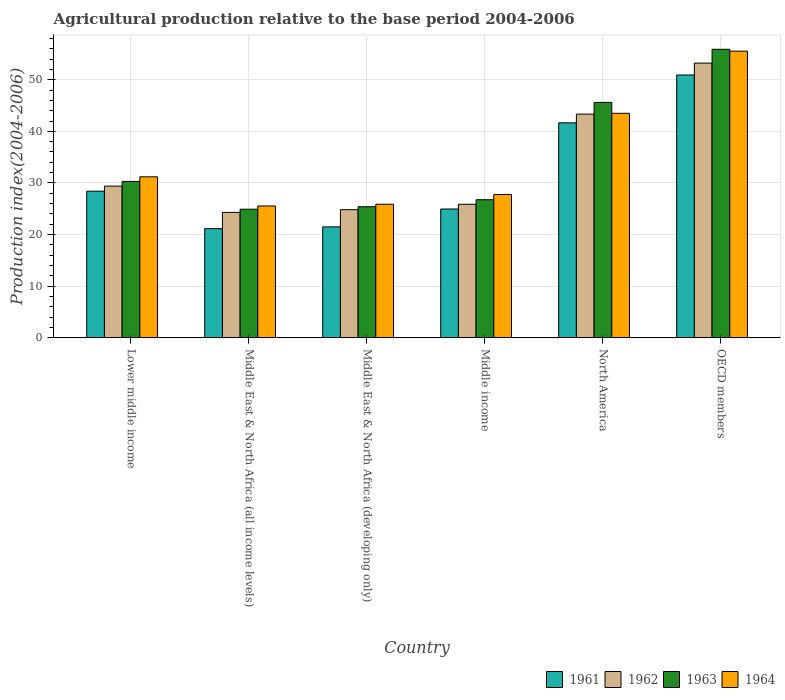How many different coloured bars are there?
Offer a very short reply. 4. How many bars are there on the 6th tick from the right?
Provide a succinct answer. 4. What is the label of the 5th group of bars from the left?
Make the answer very short. North America. In how many cases, is the number of bars for a given country not equal to the number of legend labels?
Provide a short and direct response. 0. What is the agricultural production index in 1961 in Lower middle income?
Make the answer very short. 28.39. Across all countries, what is the maximum agricultural production index in 1964?
Your answer should be compact. 55.54. Across all countries, what is the minimum agricultural production index in 1962?
Offer a terse response. 24.29. In which country was the agricultural production index in 1962 minimum?
Your answer should be compact. Middle East & North Africa (all income levels). What is the total agricultural production index in 1964 in the graph?
Offer a very short reply. 209.37. What is the difference between the agricultural production index in 1962 in Middle East & North Africa (all income levels) and that in Middle income?
Your response must be concise. -1.57. What is the difference between the agricultural production index in 1963 in OECD members and the agricultural production index in 1962 in North America?
Offer a terse response. 12.57. What is the average agricultural production index in 1961 per country?
Offer a very short reply. 31.42. What is the difference between the agricultural production index of/in 1961 and agricultural production index of/in 1963 in Lower middle income?
Provide a succinct answer. -1.9. In how many countries, is the agricultural production index in 1964 greater than 54?
Offer a very short reply. 1. What is the ratio of the agricultural production index in 1962 in Middle East & North Africa (developing only) to that in Middle income?
Provide a short and direct response. 0.96. What is the difference between the highest and the second highest agricultural production index in 1963?
Provide a short and direct response. 15.32. What is the difference between the highest and the lowest agricultural production index in 1963?
Ensure brevity in your answer.  31. Is it the case that in every country, the sum of the agricultural production index in 1962 and agricultural production index in 1964 is greater than the sum of agricultural production index in 1961 and agricultural production index in 1963?
Your answer should be very brief. No. What does the 2nd bar from the right in North America represents?
Give a very brief answer. 1963. How many bars are there?
Keep it short and to the point. 24. Are all the bars in the graph horizontal?
Give a very brief answer. No. How many countries are there in the graph?
Give a very brief answer. 6. What is the difference between two consecutive major ticks on the Y-axis?
Make the answer very short. 10. Are the values on the major ticks of Y-axis written in scientific E-notation?
Your answer should be compact. No. Does the graph contain any zero values?
Your response must be concise. No. How many legend labels are there?
Keep it short and to the point. 4. How are the legend labels stacked?
Offer a terse response. Horizontal. What is the title of the graph?
Your response must be concise. Agricultural production relative to the base period 2004-2006. What is the label or title of the X-axis?
Your answer should be compact. Country. What is the label or title of the Y-axis?
Make the answer very short. Production index(2004-2006). What is the Production index(2004-2006) of 1961 in Lower middle income?
Offer a terse response. 28.39. What is the Production index(2004-2006) in 1962 in Lower middle income?
Your response must be concise. 29.38. What is the Production index(2004-2006) of 1963 in Lower middle income?
Ensure brevity in your answer.  30.29. What is the Production index(2004-2006) of 1964 in Lower middle income?
Give a very brief answer. 31.18. What is the Production index(2004-2006) of 1961 in Middle East & North Africa (all income levels)?
Offer a very short reply. 21.14. What is the Production index(2004-2006) in 1962 in Middle East & North Africa (all income levels)?
Make the answer very short. 24.29. What is the Production index(2004-2006) of 1963 in Middle East & North Africa (all income levels)?
Your response must be concise. 24.9. What is the Production index(2004-2006) in 1964 in Middle East & North Africa (all income levels)?
Give a very brief answer. 25.53. What is the Production index(2004-2006) of 1961 in Middle East & North Africa (developing only)?
Make the answer very short. 21.48. What is the Production index(2004-2006) of 1962 in Middle East & North Africa (developing only)?
Offer a terse response. 24.81. What is the Production index(2004-2006) of 1963 in Middle East & North Africa (developing only)?
Offer a very short reply. 25.39. What is the Production index(2004-2006) of 1964 in Middle East & North Africa (developing only)?
Make the answer very short. 25.86. What is the Production index(2004-2006) of 1961 in Middle income?
Offer a very short reply. 24.94. What is the Production index(2004-2006) in 1962 in Middle income?
Offer a terse response. 25.86. What is the Production index(2004-2006) in 1963 in Middle income?
Keep it short and to the point. 26.74. What is the Production index(2004-2006) in 1964 in Middle income?
Your answer should be very brief. 27.75. What is the Production index(2004-2006) of 1961 in North America?
Your answer should be very brief. 41.65. What is the Production index(2004-2006) in 1962 in North America?
Ensure brevity in your answer.  43.33. What is the Production index(2004-2006) of 1963 in North America?
Make the answer very short. 45.61. What is the Production index(2004-2006) in 1964 in North America?
Give a very brief answer. 43.5. What is the Production index(2004-2006) of 1961 in OECD members?
Keep it short and to the point. 50.92. What is the Production index(2004-2006) in 1962 in OECD members?
Give a very brief answer. 53.23. What is the Production index(2004-2006) of 1963 in OECD members?
Provide a short and direct response. 55.9. What is the Production index(2004-2006) in 1964 in OECD members?
Keep it short and to the point. 55.54. Across all countries, what is the maximum Production index(2004-2006) in 1961?
Your answer should be very brief. 50.92. Across all countries, what is the maximum Production index(2004-2006) of 1962?
Provide a succinct answer. 53.23. Across all countries, what is the maximum Production index(2004-2006) in 1963?
Ensure brevity in your answer.  55.9. Across all countries, what is the maximum Production index(2004-2006) in 1964?
Give a very brief answer. 55.54. Across all countries, what is the minimum Production index(2004-2006) of 1961?
Your response must be concise. 21.14. Across all countries, what is the minimum Production index(2004-2006) of 1962?
Your answer should be compact. 24.29. Across all countries, what is the minimum Production index(2004-2006) in 1963?
Provide a short and direct response. 24.9. Across all countries, what is the minimum Production index(2004-2006) of 1964?
Offer a terse response. 25.53. What is the total Production index(2004-2006) in 1961 in the graph?
Keep it short and to the point. 188.52. What is the total Production index(2004-2006) in 1962 in the graph?
Your answer should be very brief. 200.9. What is the total Production index(2004-2006) in 1963 in the graph?
Your answer should be very brief. 208.83. What is the total Production index(2004-2006) in 1964 in the graph?
Offer a very short reply. 209.37. What is the difference between the Production index(2004-2006) of 1961 in Lower middle income and that in Middle East & North Africa (all income levels)?
Provide a short and direct response. 7.26. What is the difference between the Production index(2004-2006) in 1962 in Lower middle income and that in Middle East & North Africa (all income levels)?
Make the answer very short. 5.09. What is the difference between the Production index(2004-2006) of 1963 in Lower middle income and that in Middle East & North Africa (all income levels)?
Your answer should be very brief. 5.39. What is the difference between the Production index(2004-2006) in 1964 in Lower middle income and that in Middle East & North Africa (all income levels)?
Your response must be concise. 5.66. What is the difference between the Production index(2004-2006) of 1961 in Lower middle income and that in Middle East & North Africa (developing only)?
Make the answer very short. 6.92. What is the difference between the Production index(2004-2006) of 1962 in Lower middle income and that in Middle East & North Africa (developing only)?
Provide a short and direct response. 4.57. What is the difference between the Production index(2004-2006) of 1963 in Lower middle income and that in Middle East & North Africa (developing only)?
Give a very brief answer. 4.9. What is the difference between the Production index(2004-2006) of 1964 in Lower middle income and that in Middle East & North Africa (developing only)?
Ensure brevity in your answer.  5.32. What is the difference between the Production index(2004-2006) of 1961 in Lower middle income and that in Middle income?
Make the answer very short. 3.45. What is the difference between the Production index(2004-2006) of 1962 in Lower middle income and that in Middle income?
Make the answer very short. 3.52. What is the difference between the Production index(2004-2006) in 1963 in Lower middle income and that in Middle income?
Offer a terse response. 3.55. What is the difference between the Production index(2004-2006) in 1964 in Lower middle income and that in Middle income?
Provide a short and direct response. 3.43. What is the difference between the Production index(2004-2006) in 1961 in Lower middle income and that in North America?
Your response must be concise. -13.25. What is the difference between the Production index(2004-2006) in 1962 in Lower middle income and that in North America?
Give a very brief answer. -13.96. What is the difference between the Production index(2004-2006) of 1963 in Lower middle income and that in North America?
Provide a succinct answer. -15.32. What is the difference between the Production index(2004-2006) of 1964 in Lower middle income and that in North America?
Your response must be concise. -12.32. What is the difference between the Production index(2004-2006) in 1961 in Lower middle income and that in OECD members?
Give a very brief answer. -22.53. What is the difference between the Production index(2004-2006) in 1962 in Lower middle income and that in OECD members?
Your answer should be compact. -23.85. What is the difference between the Production index(2004-2006) in 1963 in Lower middle income and that in OECD members?
Provide a succinct answer. -25.61. What is the difference between the Production index(2004-2006) of 1964 in Lower middle income and that in OECD members?
Offer a very short reply. -24.36. What is the difference between the Production index(2004-2006) of 1961 in Middle East & North Africa (all income levels) and that in Middle East & North Africa (developing only)?
Keep it short and to the point. -0.34. What is the difference between the Production index(2004-2006) of 1962 in Middle East & North Africa (all income levels) and that in Middle East & North Africa (developing only)?
Your answer should be very brief. -0.52. What is the difference between the Production index(2004-2006) of 1963 in Middle East & North Africa (all income levels) and that in Middle East & North Africa (developing only)?
Your answer should be very brief. -0.48. What is the difference between the Production index(2004-2006) in 1964 in Middle East & North Africa (all income levels) and that in Middle East & North Africa (developing only)?
Offer a terse response. -0.34. What is the difference between the Production index(2004-2006) in 1961 in Middle East & North Africa (all income levels) and that in Middle income?
Provide a short and direct response. -3.8. What is the difference between the Production index(2004-2006) of 1962 in Middle East & North Africa (all income levels) and that in Middle income?
Keep it short and to the point. -1.57. What is the difference between the Production index(2004-2006) in 1963 in Middle East & North Africa (all income levels) and that in Middle income?
Give a very brief answer. -1.84. What is the difference between the Production index(2004-2006) of 1964 in Middle East & North Africa (all income levels) and that in Middle income?
Give a very brief answer. -2.23. What is the difference between the Production index(2004-2006) of 1961 in Middle East & North Africa (all income levels) and that in North America?
Offer a terse response. -20.51. What is the difference between the Production index(2004-2006) in 1962 in Middle East & North Africa (all income levels) and that in North America?
Offer a very short reply. -19.05. What is the difference between the Production index(2004-2006) of 1963 in Middle East & North Africa (all income levels) and that in North America?
Offer a terse response. -20.71. What is the difference between the Production index(2004-2006) of 1964 in Middle East & North Africa (all income levels) and that in North America?
Offer a terse response. -17.97. What is the difference between the Production index(2004-2006) in 1961 in Middle East & North Africa (all income levels) and that in OECD members?
Your answer should be compact. -29.79. What is the difference between the Production index(2004-2006) in 1962 in Middle East & North Africa (all income levels) and that in OECD members?
Make the answer very short. -28.94. What is the difference between the Production index(2004-2006) in 1963 in Middle East & North Africa (all income levels) and that in OECD members?
Offer a terse response. -31. What is the difference between the Production index(2004-2006) of 1964 in Middle East & North Africa (all income levels) and that in OECD members?
Offer a terse response. -30.02. What is the difference between the Production index(2004-2006) in 1961 in Middle East & North Africa (developing only) and that in Middle income?
Keep it short and to the point. -3.47. What is the difference between the Production index(2004-2006) of 1962 in Middle East & North Africa (developing only) and that in Middle income?
Give a very brief answer. -1.04. What is the difference between the Production index(2004-2006) in 1963 in Middle East & North Africa (developing only) and that in Middle income?
Provide a short and direct response. -1.35. What is the difference between the Production index(2004-2006) of 1964 in Middle East & North Africa (developing only) and that in Middle income?
Your response must be concise. -1.89. What is the difference between the Production index(2004-2006) of 1961 in Middle East & North Africa (developing only) and that in North America?
Provide a succinct answer. -20.17. What is the difference between the Production index(2004-2006) of 1962 in Middle East & North Africa (developing only) and that in North America?
Offer a terse response. -18.52. What is the difference between the Production index(2004-2006) of 1963 in Middle East & North Africa (developing only) and that in North America?
Your answer should be compact. -20.22. What is the difference between the Production index(2004-2006) in 1964 in Middle East & North Africa (developing only) and that in North America?
Offer a very short reply. -17.63. What is the difference between the Production index(2004-2006) of 1961 in Middle East & North Africa (developing only) and that in OECD members?
Make the answer very short. -29.45. What is the difference between the Production index(2004-2006) of 1962 in Middle East & North Africa (developing only) and that in OECD members?
Keep it short and to the point. -28.42. What is the difference between the Production index(2004-2006) of 1963 in Middle East & North Africa (developing only) and that in OECD members?
Keep it short and to the point. -30.52. What is the difference between the Production index(2004-2006) of 1964 in Middle East & North Africa (developing only) and that in OECD members?
Offer a terse response. -29.68. What is the difference between the Production index(2004-2006) in 1961 in Middle income and that in North America?
Offer a terse response. -16.71. What is the difference between the Production index(2004-2006) in 1962 in Middle income and that in North America?
Provide a succinct answer. -17.48. What is the difference between the Production index(2004-2006) of 1963 in Middle income and that in North America?
Give a very brief answer. -18.87. What is the difference between the Production index(2004-2006) of 1964 in Middle income and that in North America?
Your answer should be very brief. -15.75. What is the difference between the Production index(2004-2006) in 1961 in Middle income and that in OECD members?
Offer a very short reply. -25.98. What is the difference between the Production index(2004-2006) in 1962 in Middle income and that in OECD members?
Keep it short and to the point. -27.37. What is the difference between the Production index(2004-2006) of 1963 in Middle income and that in OECD members?
Offer a terse response. -29.16. What is the difference between the Production index(2004-2006) in 1964 in Middle income and that in OECD members?
Your answer should be compact. -27.79. What is the difference between the Production index(2004-2006) in 1961 in North America and that in OECD members?
Make the answer very short. -9.28. What is the difference between the Production index(2004-2006) of 1962 in North America and that in OECD members?
Provide a succinct answer. -9.9. What is the difference between the Production index(2004-2006) of 1963 in North America and that in OECD members?
Your answer should be compact. -10.3. What is the difference between the Production index(2004-2006) in 1964 in North America and that in OECD members?
Offer a very short reply. -12.04. What is the difference between the Production index(2004-2006) in 1961 in Lower middle income and the Production index(2004-2006) in 1962 in Middle East & North Africa (all income levels)?
Offer a terse response. 4.11. What is the difference between the Production index(2004-2006) in 1961 in Lower middle income and the Production index(2004-2006) in 1963 in Middle East & North Africa (all income levels)?
Your answer should be very brief. 3.49. What is the difference between the Production index(2004-2006) of 1961 in Lower middle income and the Production index(2004-2006) of 1964 in Middle East & North Africa (all income levels)?
Provide a short and direct response. 2.87. What is the difference between the Production index(2004-2006) of 1962 in Lower middle income and the Production index(2004-2006) of 1963 in Middle East & North Africa (all income levels)?
Keep it short and to the point. 4.48. What is the difference between the Production index(2004-2006) in 1962 in Lower middle income and the Production index(2004-2006) in 1964 in Middle East & North Africa (all income levels)?
Your answer should be very brief. 3.85. What is the difference between the Production index(2004-2006) of 1963 in Lower middle income and the Production index(2004-2006) of 1964 in Middle East & North Africa (all income levels)?
Make the answer very short. 4.76. What is the difference between the Production index(2004-2006) of 1961 in Lower middle income and the Production index(2004-2006) of 1962 in Middle East & North Africa (developing only)?
Ensure brevity in your answer.  3.58. What is the difference between the Production index(2004-2006) in 1961 in Lower middle income and the Production index(2004-2006) in 1963 in Middle East & North Africa (developing only)?
Offer a terse response. 3.01. What is the difference between the Production index(2004-2006) in 1961 in Lower middle income and the Production index(2004-2006) in 1964 in Middle East & North Africa (developing only)?
Your response must be concise. 2.53. What is the difference between the Production index(2004-2006) in 1962 in Lower middle income and the Production index(2004-2006) in 1963 in Middle East & North Africa (developing only)?
Offer a very short reply. 3.99. What is the difference between the Production index(2004-2006) in 1962 in Lower middle income and the Production index(2004-2006) in 1964 in Middle East & North Africa (developing only)?
Your response must be concise. 3.51. What is the difference between the Production index(2004-2006) in 1963 in Lower middle income and the Production index(2004-2006) in 1964 in Middle East & North Africa (developing only)?
Provide a short and direct response. 4.43. What is the difference between the Production index(2004-2006) of 1961 in Lower middle income and the Production index(2004-2006) of 1962 in Middle income?
Offer a terse response. 2.54. What is the difference between the Production index(2004-2006) in 1961 in Lower middle income and the Production index(2004-2006) in 1963 in Middle income?
Ensure brevity in your answer.  1.65. What is the difference between the Production index(2004-2006) in 1961 in Lower middle income and the Production index(2004-2006) in 1964 in Middle income?
Offer a very short reply. 0.64. What is the difference between the Production index(2004-2006) of 1962 in Lower middle income and the Production index(2004-2006) of 1963 in Middle income?
Keep it short and to the point. 2.64. What is the difference between the Production index(2004-2006) in 1962 in Lower middle income and the Production index(2004-2006) in 1964 in Middle income?
Ensure brevity in your answer.  1.63. What is the difference between the Production index(2004-2006) in 1963 in Lower middle income and the Production index(2004-2006) in 1964 in Middle income?
Offer a terse response. 2.54. What is the difference between the Production index(2004-2006) of 1961 in Lower middle income and the Production index(2004-2006) of 1962 in North America?
Offer a very short reply. -14.94. What is the difference between the Production index(2004-2006) in 1961 in Lower middle income and the Production index(2004-2006) in 1963 in North America?
Your answer should be very brief. -17.21. What is the difference between the Production index(2004-2006) in 1961 in Lower middle income and the Production index(2004-2006) in 1964 in North America?
Ensure brevity in your answer.  -15.1. What is the difference between the Production index(2004-2006) of 1962 in Lower middle income and the Production index(2004-2006) of 1963 in North America?
Keep it short and to the point. -16.23. What is the difference between the Production index(2004-2006) in 1962 in Lower middle income and the Production index(2004-2006) in 1964 in North America?
Provide a short and direct response. -14.12. What is the difference between the Production index(2004-2006) in 1963 in Lower middle income and the Production index(2004-2006) in 1964 in North America?
Ensure brevity in your answer.  -13.21. What is the difference between the Production index(2004-2006) in 1961 in Lower middle income and the Production index(2004-2006) in 1962 in OECD members?
Ensure brevity in your answer.  -24.84. What is the difference between the Production index(2004-2006) of 1961 in Lower middle income and the Production index(2004-2006) of 1963 in OECD members?
Your response must be concise. -27.51. What is the difference between the Production index(2004-2006) in 1961 in Lower middle income and the Production index(2004-2006) in 1964 in OECD members?
Your answer should be compact. -27.15. What is the difference between the Production index(2004-2006) in 1962 in Lower middle income and the Production index(2004-2006) in 1963 in OECD members?
Ensure brevity in your answer.  -26.52. What is the difference between the Production index(2004-2006) in 1962 in Lower middle income and the Production index(2004-2006) in 1964 in OECD members?
Ensure brevity in your answer.  -26.16. What is the difference between the Production index(2004-2006) of 1963 in Lower middle income and the Production index(2004-2006) of 1964 in OECD members?
Your answer should be very brief. -25.25. What is the difference between the Production index(2004-2006) of 1961 in Middle East & North Africa (all income levels) and the Production index(2004-2006) of 1962 in Middle East & North Africa (developing only)?
Your answer should be compact. -3.68. What is the difference between the Production index(2004-2006) in 1961 in Middle East & North Africa (all income levels) and the Production index(2004-2006) in 1963 in Middle East & North Africa (developing only)?
Offer a terse response. -4.25. What is the difference between the Production index(2004-2006) of 1961 in Middle East & North Africa (all income levels) and the Production index(2004-2006) of 1964 in Middle East & North Africa (developing only)?
Keep it short and to the point. -4.73. What is the difference between the Production index(2004-2006) of 1962 in Middle East & North Africa (all income levels) and the Production index(2004-2006) of 1963 in Middle East & North Africa (developing only)?
Give a very brief answer. -1.1. What is the difference between the Production index(2004-2006) of 1962 in Middle East & North Africa (all income levels) and the Production index(2004-2006) of 1964 in Middle East & North Africa (developing only)?
Keep it short and to the point. -1.58. What is the difference between the Production index(2004-2006) of 1963 in Middle East & North Africa (all income levels) and the Production index(2004-2006) of 1964 in Middle East & North Africa (developing only)?
Your answer should be very brief. -0.96. What is the difference between the Production index(2004-2006) in 1961 in Middle East & North Africa (all income levels) and the Production index(2004-2006) in 1962 in Middle income?
Offer a very short reply. -4.72. What is the difference between the Production index(2004-2006) of 1961 in Middle East & North Africa (all income levels) and the Production index(2004-2006) of 1963 in Middle income?
Provide a short and direct response. -5.6. What is the difference between the Production index(2004-2006) of 1961 in Middle East & North Africa (all income levels) and the Production index(2004-2006) of 1964 in Middle income?
Keep it short and to the point. -6.61. What is the difference between the Production index(2004-2006) in 1962 in Middle East & North Africa (all income levels) and the Production index(2004-2006) in 1963 in Middle income?
Offer a very short reply. -2.45. What is the difference between the Production index(2004-2006) in 1962 in Middle East & North Africa (all income levels) and the Production index(2004-2006) in 1964 in Middle income?
Provide a short and direct response. -3.46. What is the difference between the Production index(2004-2006) of 1963 in Middle East & North Africa (all income levels) and the Production index(2004-2006) of 1964 in Middle income?
Your answer should be compact. -2.85. What is the difference between the Production index(2004-2006) of 1961 in Middle East & North Africa (all income levels) and the Production index(2004-2006) of 1962 in North America?
Offer a very short reply. -22.2. What is the difference between the Production index(2004-2006) in 1961 in Middle East & North Africa (all income levels) and the Production index(2004-2006) in 1963 in North America?
Offer a very short reply. -24.47. What is the difference between the Production index(2004-2006) of 1961 in Middle East & North Africa (all income levels) and the Production index(2004-2006) of 1964 in North America?
Offer a terse response. -22.36. What is the difference between the Production index(2004-2006) of 1962 in Middle East & North Africa (all income levels) and the Production index(2004-2006) of 1963 in North America?
Your answer should be very brief. -21.32. What is the difference between the Production index(2004-2006) of 1962 in Middle East & North Africa (all income levels) and the Production index(2004-2006) of 1964 in North America?
Make the answer very short. -19.21. What is the difference between the Production index(2004-2006) of 1963 in Middle East & North Africa (all income levels) and the Production index(2004-2006) of 1964 in North America?
Your answer should be compact. -18.6. What is the difference between the Production index(2004-2006) in 1961 in Middle East & North Africa (all income levels) and the Production index(2004-2006) in 1962 in OECD members?
Offer a terse response. -32.09. What is the difference between the Production index(2004-2006) of 1961 in Middle East & North Africa (all income levels) and the Production index(2004-2006) of 1963 in OECD members?
Your answer should be compact. -34.77. What is the difference between the Production index(2004-2006) in 1961 in Middle East & North Africa (all income levels) and the Production index(2004-2006) in 1964 in OECD members?
Offer a very short reply. -34.4. What is the difference between the Production index(2004-2006) of 1962 in Middle East & North Africa (all income levels) and the Production index(2004-2006) of 1963 in OECD members?
Keep it short and to the point. -31.62. What is the difference between the Production index(2004-2006) of 1962 in Middle East & North Africa (all income levels) and the Production index(2004-2006) of 1964 in OECD members?
Provide a short and direct response. -31.25. What is the difference between the Production index(2004-2006) of 1963 in Middle East & North Africa (all income levels) and the Production index(2004-2006) of 1964 in OECD members?
Offer a terse response. -30.64. What is the difference between the Production index(2004-2006) of 1961 in Middle East & North Africa (developing only) and the Production index(2004-2006) of 1962 in Middle income?
Ensure brevity in your answer.  -4.38. What is the difference between the Production index(2004-2006) in 1961 in Middle East & North Africa (developing only) and the Production index(2004-2006) in 1963 in Middle income?
Keep it short and to the point. -5.26. What is the difference between the Production index(2004-2006) in 1961 in Middle East & North Africa (developing only) and the Production index(2004-2006) in 1964 in Middle income?
Give a very brief answer. -6.28. What is the difference between the Production index(2004-2006) in 1962 in Middle East & North Africa (developing only) and the Production index(2004-2006) in 1963 in Middle income?
Keep it short and to the point. -1.93. What is the difference between the Production index(2004-2006) in 1962 in Middle East & North Africa (developing only) and the Production index(2004-2006) in 1964 in Middle income?
Your response must be concise. -2.94. What is the difference between the Production index(2004-2006) of 1963 in Middle East & North Africa (developing only) and the Production index(2004-2006) of 1964 in Middle income?
Ensure brevity in your answer.  -2.37. What is the difference between the Production index(2004-2006) of 1961 in Middle East & North Africa (developing only) and the Production index(2004-2006) of 1962 in North America?
Your response must be concise. -21.86. What is the difference between the Production index(2004-2006) of 1961 in Middle East & North Africa (developing only) and the Production index(2004-2006) of 1963 in North America?
Ensure brevity in your answer.  -24.13. What is the difference between the Production index(2004-2006) of 1961 in Middle East & North Africa (developing only) and the Production index(2004-2006) of 1964 in North America?
Ensure brevity in your answer.  -22.02. What is the difference between the Production index(2004-2006) in 1962 in Middle East & North Africa (developing only) and the Production index(2004-2006) in 1963 in North America?
Keep it short and to the point. -20.79. What is the difference between the Production index(2004-2006) of 1962 in Middle East & North Africa (developing only) and the Production index(2004-2006) of 1964 in North America?
Your response must be concise. -18.69. What is the difference between the Production index(2004-2006) in 1963 in Middle East & North Africa (developing only) and the Production index(2004-2006) in 1964 in North America?
Keep it short and to the point. -18.11. What is the difference between the Production index(2004-2006) of 1961 in Middle East & North Africa (developing only) and the Production index(2004-2006) of 1962 in OECD members?
Your answer should be compact. -31.76. What is the difference between the Production index(2004-2006) in 1961 in Middle East & North Africa (developing only) and the Production index(2004-2006) in 1963 in OECD members?
Provide a short and direct response. -34.43. What is the difference between the Production index(2004-2006) in 1961 in Middle East & North Africa (developing only) and the Production index(2004-2006) in 1964 in OECD members?
Your response must be concise. -34.07. What is the difference between the Production index(2004-2006) in 1962 in Middle East & North Africa (developing only) and the Production index(2004-2006) in 1963 in OECD members?
Ensure brevity in your answer.  -31.09. What is the difference between the Production index(2004-2006) in 1962 in Middle East & North Africa (developing only) and the Production index(2004-2006) in 1964 in OECD members?
Keep it short and to the point. -30.73. What is the difference between the Production index(2004-2006) of 1963 in Middle East & North Africa (developing only) and the Production index(2004-2006) of 1964 in OECD members?
Your answer should be compact. -30.16. What is the difference between the Production index(2004-2006) in 1961 in Middle income and the Production index(2004-2006) in 1962 in North America?
Your response must be concise. -18.39. What is the difference between the Production index(2004-2006) of 1961 in Middle income and the Production index(2004-2006) of 1963 in North America?
Offer a terse response. -20.67. What is the difference between the Production index(2004-2006) in 1961 in Middle income and the Production index(2004-2006) in 1964 in North America?
Offer a very short reply. -18.56. What is the difference between the Production index(2004-2006) in 1962 in Middle income and the Production index(2004-2006) in 1963 in North America?
Keep it short and to the point. -19.75. What is the difference between the Production index(2004-2006) in 1962 in Middle income and the Production index(2004-2006) in 1964 in North America?
Give a very brief answer. -17.64. What is the difference between the Production index(2004-2006) of 1963 in Middle income and the Production index(2004-2006) of 1964 in North America?
Ensure brevity in your answer.  -16.76. What is the difference between the Production index(2004-2006) of 1961 in Middle income and the Production index(2004-2006) of 1962 in OECD members?
Provide a succinct answer. -28.29. What is the difference between the Production index(2004-2006) of 1961 in Middle income and the Production index(2004-2006) of 1963 in OECD members?
Offer a very short reply. -30.96. What is the difference between the Production index(2004-2006) in 1961 in Middle income and the Production index(2004-2006) in 1964 in OECD members?
Offer a terse response. -30.6. What is the difference between the Production index(2004-2006) of 1962 in Middle income and the Production index(2004-2006) of 1963 in OECD members?
Offer a terse response. -30.05. What is the difference between the Production index(2004-2006) of 1962 in Middle income and the Production index(2004-2006) of 1964 in OECD members?
Offer a terse response. -29.68. What is the difference between the Production index(2004-2006) of 1963 in Middle income and the Production index(2004-2006) of 1964 in OECD members?
Offer a terse response. -28.8. What is the difference between the Production index(2004-2006) of 1961 in North America and the Production index(2004-2006) of 1962 in OECD members?
Offer a terse response. -11.58. What is the difference between the Production index(2004-2006) in 1961 in North America and the Production index(2004-2006) in 1963 in OECD members?
Your response must be concise. -14.26. What is the difference between the Production index(2004-2006) of 1961 in North America and the Production index(2004-2006) of 1964 in OECD members?
Make the answer very short. -13.9. What is the difference between the Production index(2004-2006) in 1962 in North America and the Production index(2004-2006) in 1963 in OECD members?
Your answer should be very brief. -12.57. What is the difference between the Production index(2004-2006) of 1962 in North America and the Production index(2004-2006) of 1964 in OECD members?
Give a very brief answer. -12.21. What is the difference between the Production index(2004-2006) in 1963 in North America and the Production index(2004-2006) in 1964 in OECD members?
Provide a short and direct response. -9.93. What is the average Production index(2004-2006) of 1961 per country?
Provide a succinct answer. 31.42. What is the average Production index(2004-2006) in 1962 per country?
Give a very brief answer. 33.48. What is the average Production index(2004-2006) in 1963 per country?
Provide a succinct answer. 34.8. What is the average Production index(2004-2006) in 1964 per country?
Your answer should be very brief. 34.89. What is the difference between the Production index(2004-2006) of 1961 and Production index(2004-2006) of 1962 in Lower middle income?
Ensure brevity in your answer.  -0.99. What is the difference between the Production index(2004-2006) of 1961 and Production index(2004-2006) of 1963 in Lower middle income?
Your answer should be very brief. -1.9. What is the difference between the Production index(2004-2006) in 1961 and Production index(2004-2006) in 1964 in Lower middle income?
Ensure brevity in your answer.  -2.79. What is the difference between the Production index(2004-2006) in 1962 and Production index(2004-2006) in 1963 in Lower middle income?
Give a very brief answer. -0.91. What is the difference between the Production index(2004-2006) of 1962 and Production index(2004-2006) of 1964 in Lower middle income?
Offer a terse response. -1.8. What is the difference between the Production index(2004-2006) in 1963 and Production index(2004-2006) in 1964 in Lower middle income?
Give a very brief answer. -0.89. What is the difference between the Production index(2004-2006) in 1961 and Production index(2004-2006) in 1962 in Middle East & North Africa (all income levels)?
Ensure brevity in your answer.  -3.15. What is the difference between the Production index(2004-2006) in 1961 and Production index(2004-2006) in 1963 in Middle East & North Africa (all income levels)?
Your answer should be very brief. -3.76. What is the difference between the Production index(2004-2006) of 1961 and Production index(2004-2006) of 1964 in Middle East & North Africa (all income levels)?
Give a very brief answer. -4.39. What is the difference between the Production index(2004-2006) in 1962 and Production index(2004-2006) in 1963 in Middle East & North Africa (all income levels)?
Offer a very short reply. -0.61. What is the difference between the Production index(2004-2006) of 1962 and Production index(2004-2006) of 1964 in Middle East & North Africa (all income levels)?
Your answer should be very brief. -1.24. What is the difference between the Production index(2004-2006) of 1963 and Production index(2004-2006) of 1964 in Middle East & North Africa (all income levels)?
Provide a short and direct response. -0.62. What is the difference between the Production index(2004-2006) of 1961 and Production index(2004-2006) of 1962 in Middle East & North Africa (developing only)?
Offer a terse response. -3.34. What is the difference between the Production index(2004-2006) in 1961 and Production index(2004-2006) in 1963 in Middle East & North Africa (developing only)?
Ensure brevity in your answer.  -3.91. What is the difference between the Production index(2004-2006) of 1961 and Production index(2004-2006) of 1964 in Middle East & North Africa (developing only)?
Offer a terse response. -4.39. What is the difference between the Production index(2004-2006) of 1962 and Production index(2004-2006) of 1963 in Middle East & North Africa (developing only)?
Your answer should be very brief. -0.57. What is the difference between the Production index(2004-2006) of 1962 and Production index(2004-2006) of 1964 in Middle East & North Africa (developing only)?
Keep it short and to the point. -1.05. What is the difference between the Production index(2004-2006) of 1963 and Production index(2004-2006) of 1964 in Middle East & North Africa (developing only)?
Give a very brief answer. -0.48. What is the difference between the Production index(2004-2006) of 1961 and Production index(2004-2006) of 1962 in Middle income?
Your answer should be very brief. -0.92. What is the difference between the Production index(2004-2006) of 1961 and Production index(2004-2006) of 1963 in Middle income?
Offer a terse response. -1.8. What is the difference between the Production index(2004-2006) in 1961 and Production index(2004-2006) in 1964 in Middle income?
Offer a very short reply. -2.81. What is the difference between the Production index(2004-2006) of 1962 and Production index(2004-2006) of 1963 in Middle income?
Your answer should be very brief. -0.88. What is the difference between the Production index(2004-2006) of 1962 and Production index(2004-2006) of 1964 in Middle income?
Ensure brevity in your answer.  -1.89. What is the difference between the Production index(2004-2006) of 1963 and Production index(2004-2006) of 1964 in Middle income?
Your answer should be very brief. -1.01. What is the difference between the Production index(2004-2006) of 1961 and Production index(2004-2006) of 1962 in North America?
Ensure brevity in your answer.  -1.69. What is the difference between the Production index(2004-2006) of 1961 and Production index(2004-2006) of 1963 in North America?
Offer a terse response. -3.96. What is the difference between the Production index(2004-2006) of 1961 and Production index(2004-2006) of 1964 in North America?
Provide a succinct answer. -1.85. What is the difference between the Production index(2004-2006) of 1962 and Production index(2004-2006) of 1963 in North America?
Make the answer very short. -2.27. What is the difference between the Production index(2004-2006) of 1962 and Production index(2004-2006) of 1964 in North America?
Ensure brevity in your answer.  -0.16. What is the difference between the Production index(2004-2006) of 1963 and Production index(2004-2006) of 1964 in North America?
Provide a short and direct response. 2.11. What is the difference between the Production index(2004-2006) in 1961 and Production index(2004-2006) in 1962 in OECD members?
Provide a short and direct response. -2.31. What is the difference between the Production index(2004-2006) in 1961 and Production index(2004-2006) in 1963 in OECD members?
Give a very brief answer. -4.98. What is the difference between the Production index(2004-2006) in 1961 and Production index(2004-2006) in 1964 in OECD members?
Give a very brief answer. -4.62. What is the difference between the Production index(2004-2006) of 1962 and Production index(2004-2006) of 1963 in OECD members?
Your response must be concise. -2.67. What is the difference between the Production index(2004-2006) of 1962 and Production index(2004-2006) of 1964 in OECD members?
Ensure brevity in your answer.  -2.31. What is the difference between the Production index(2004-2006) of 1963 and Production index(2004-2006) of 1964 in OECD members?
Make the answer very short. 0.36. What is the ratio of the Production index(2004-2006) of 1961 in Lower middle income to that in Middle East & North Africa (all income levels)?
Your response must be concise. 1.34. What is the ratio of the Production index(2004-2006) in 1962 in Lower middle income to that in Middle East & North Africa (all income levels)?
Provide a succinct answer. 1.21. What is the ratio of the Production index(2004-2006) in 1963 in Lower middle income to that in Middle East & North Africa (all income levels)?
Offer a very short reply. 1.22. What is the ratio of the Production index(2004-2006) in 1964 in Lower middle income to that in Middle East & North Africa (all income levels)?
Your answer should be very brief. 1.22. What is the ratio of the Production index(2004-2006) in 1961 in Lower middle income to that in Middle East & North Africa (developing only)?
Provide a succinct answer. 1.32. What is the ratio of the Production index(2004-2006) in 1962 in Lower middle income to that in Middle East & North Africa (developing only)?
Ensure brevity in your answer.  1.18. What is the ratio of the Production index(2004-2006) in 1963 in Lower middle income to that in Middle East & North Africa (developing only)?
Your response must be concise. 1.19. What is the ratio of the Production index(2004-2006) in 1964 in Lower middle income to that in Middle East & North Africa (developing only)?
Offer a terse response. 1.21. What is the ratio of the Production index(2004-2006) of 1961 in Lower middle income to that in Middle income?
Your response must be concise. 1.14. What is the ratio of the Production index(2004-2006) in 1962 in Lower middle income to that in Middle income?
Your response must be concise. 1.14. What is the ratio of the Production index(2004-2006) in 1963 in Lower middle income to that in Middle income?
Provide a succinct answer. 1.13. What is the ratio of the Production index(2004-2006) in 1964 in Lower middle income to that in Middle income?
Ensure brevity in your answer.  1.12. What is the ratio of the Production index(2004-2006) of 1961 in Lower middle income to that in North America?
Your answer should be very brief. 0.68. What is the ratio of the Production index(2004-2006) of 1962 in Lower middle income to that in North America?
Ensure brevity in your answer.  0.68. What is the ratio of the Production index(2004-2006) of 1963 in Lower middle income to that in North America?
Provide a short and direct response. 0.66. What is the ratio of the Production index(2004-2006) of 1964 in Lower middle income to that in North America?
Your answer should be very brief. 0.72. What is the ratio of the Production index(2004-2006) of 1961 in Lower middle income to that in OECD members?
Provide a short and direct response. 0.56. What is the ratio of the Production index(2004-2006) in 1962 in Lower middle income to that in OECD members?
Give a very brief answer. 0.55. What is the ratio of the Production index(2004-2006) of 1963 in Lower middle income to that in OECD members?
Provide a succinct answer. 0.54. What is the ratio of the Production index(2004-2006) in 1964 in Lower middle income to that in OECD members?
Ensure brevity in your answer.  0.56. What is the ratio of the Production index(2004-2006) of 1961 in Middle East & North Africa (all income levels) to that in Middle East & North Africa (developing only)?
Your response must be concise. 0.98. What is the ratio of the Production index(2004-2006) of 1962 in Middle East & North Africa (all income levels) to that in Middle East & North Africa (developing only)?
Offer a very short reply. 0.98. What is the ratio of the Production index(2004-2006) in 1963 in Middle East & North Africa (all income levels) to that in Middle East & North Africa (developing only)?
Your response must be concise. 0.98. What is the ratio of the Production index(2004-2006) in 1964 in Middle East & North Africa (all income levels) to that in Middle East & North Africa (developing only)?
Your answer should be very brief. 0.99. What is the ratio of the Production index(2004-2006) in 1961 in Middle East & North Africa (all income levels) to that in Middle income?
Your answer should be very brief. 0.85. What is the ratio of the Production index(2004-2006) in 1962 in Middle East & North Africa (all income levels) to that in Middle income?
Provide a short and direct response. 0.94. What is the ratio of the Production index(2004-2006) of 1963 in Middle East & North Africa (all income levels) to that in Middle income?
Offer a very short reply. 0.93. What is the ratio of the Production index(2004-2006) in 1964 in Middle East & North Africa (all income levels) to that in Middle income?
Keep it short and to the point. 0.92. What is the ratio of the Production index(2004-2006) in 1961 in Middle East & North Africa (all income levels) to that in North America?
Keep it short and to the point. 0.51. What is the ratio of the Production index(2004-2006) of 1962 in Middle East & North Africa (all income levels) to that in North America?
Provide a short and direct response. 0.56. What is the ratio of the Production index(2004-2006) in 1963 in Middle East & North Africa (all income levels) to that in North America?
Offer a terse response. 0.55. What is the ratio of the Production index(2004-2006) of 1964 in Middle East & North Africa (all income levels) to that in North America?
Ensure brevity in your answer.  0.59. What is the ratio of the Production index(2004-2006) of 1961 in Middle East & North Africa (all income levels) to that in OECD members?
Keep it short and to the point. 0.42. What is the ratio of the Production index(2004-2006) in 1962 in Middle East & North Africa (all income levels) to that in OECD members?
Ensure brevity in your answer.  0.46. What is the ratio of the Production index(2004-2006) of 1963 in Middle East & North Africa (all income levels) to that in OECD members?
Your answer should be very brief. 0.45. What is the ratio of the Production index(2004-2006) in 1964 in Middle East & North Africa (all income levels) to that in OECD members?
Your response must be concise. 0.46. What is the ratio of the Production index(2004-2006) in 1961 in Middle East & North Africa (developing only) to that in Middle income?
Ensure brevity in your answer.  0.86. What is the ratio of the Production index(2004-2006) in 1962 in Middle East & North Africa (developing only) to that in Middle income?
Your response must be concise. 0.96. What is the ratio of the Production index(2004-2006) of 1963 in Middle East & North Africa (developing only) to that in Middle income?
Provide a succinct answer. 0.95. What is the ratio of the Production index(2004-2006) in 1964 in Middle East & North Africa (developing only) to that in Middle income?
Offer a very short reply. 0.93. What is the ratio of the Production index(2004-2006) in 1961 in Middle East & North Africa (developing only) to that in North America?
Your response must be concise. 0.52. What is the ratio of the Production index(2004-2006) in 1962 in Middle East & North Africa (developing only) to that in North America?
Offer a very short reply. 0.57. What is the ratio of the Production index(2004-2006) in 1963 in Middle East & North Africa (developing only) to that in North America?
Offer a terse response. 0.56. What is the ratio of the Production index(2004-2006) in 1964 in Middle East & North Africa (developing only) to that in North America?
Offer a terse response. 0.59. What is the ratio of the Production index(2004-2006) in 1961 in Middle East & North Africa (developing only) to that in OECD members?
Ensure brevity in your answer.  0.42. What is the ratio of the Production index(2004-2006) in 1962 in Middle East & North Africa (developing only) to that in OECD members?
Provide a succinct answer. 0.47. What is the ratio of the Production index(2004-2006) in 1963 in Middle East & North Africa (developing only) to that in OECD members?
Ensure brevity in your answer.  0.45. What is the ratio of the Production index(2004-2006) in 1964 in Middle East & North Africa (developing only) to that in OECD members?
Your answer should be compact. 0.47. What is the ratio of the Production index(2004-2006) of 1961 in Middle income to that in North America?
Make the answer very short. 0.6. What is the ratio of the Production index(2004-2006) in 1962 in Middle income to that in North America?
Your answer should be compact. 0.6. What is the ratio of the Production index(2004-2006) of 1963 in Middle income to that in North America?
Offer a very short reply. 0.59. What is the ratio of the Production index(2004-2006) of 1964 in Middle income to that in North America?
Your answer should be very brief. 0.64. What is the ratio of the Production index(2004-2006) of 1961 in Middle income to that in OECD members?
Your answer should be compact. 0.49. What is the ratio of the Production index(2004-2006) in 1962 in Middle income to that in OECD members?
Provide a succinct answer. 0.49. What is the ratio of the Production index(2004-2006) in 1963 in Middle income to that in OECD members?
Your answer should be compact. 0.48. What is the ratio of the Production index(2004-2006) of 1964 in Middle income to that in OECD members?
Offer a very short reply. 0.5. What is the ratio of the Production index(2004-2006) in 1961 in North America to that in OECD members?
Ensure brevity in your answer.  0.82. What is the ratio of the Production index(2004-2006) in 1962 in North America to that in OECD members?
Keep it short and to the point. 0.81. What is the ratio of the Production index(2004-2006) in 1963 in North America to that in OECD members?
Your answer should be compact. 0.82. What is the ratio of the Production index(2004-2006) of 1964 in North America to that in OECD members?
Ensure brevity in your answer.  0.78. What is the difference between the highest and the second highest Production index(2004-2006) of 1961?
Your answer should be very brief. 9.28. What is the difference between the highest and the second highest Production index(2004-2006) of 1962?
Your answer should be very brief. 9.9. What is the difference between the highest and the second highest Production index(2004-2006) of 1963?
Ensure brevity in your answer.  10.3. What is the difference between the highest and the second highest Production index(2004-2006) of 1964?
Your answer should be compact. 12.04. What is the difference between the highest and the lowest Production index(2004-2006) of 1961?
Keep it short and to the point. 29.79. What is the difference between the highest and the lowest Production index(2004-2006) in 1962?
Your answer should be very brief. 28.94. What is the difference between the highest and the lowest Production index(2004-2006) in 1963?
Ensure brevity in your answer.  31. What is the difference between the highest and the lowest Production index(2004-2006) in 1964?
Provide a short and direct response. 30.02. 